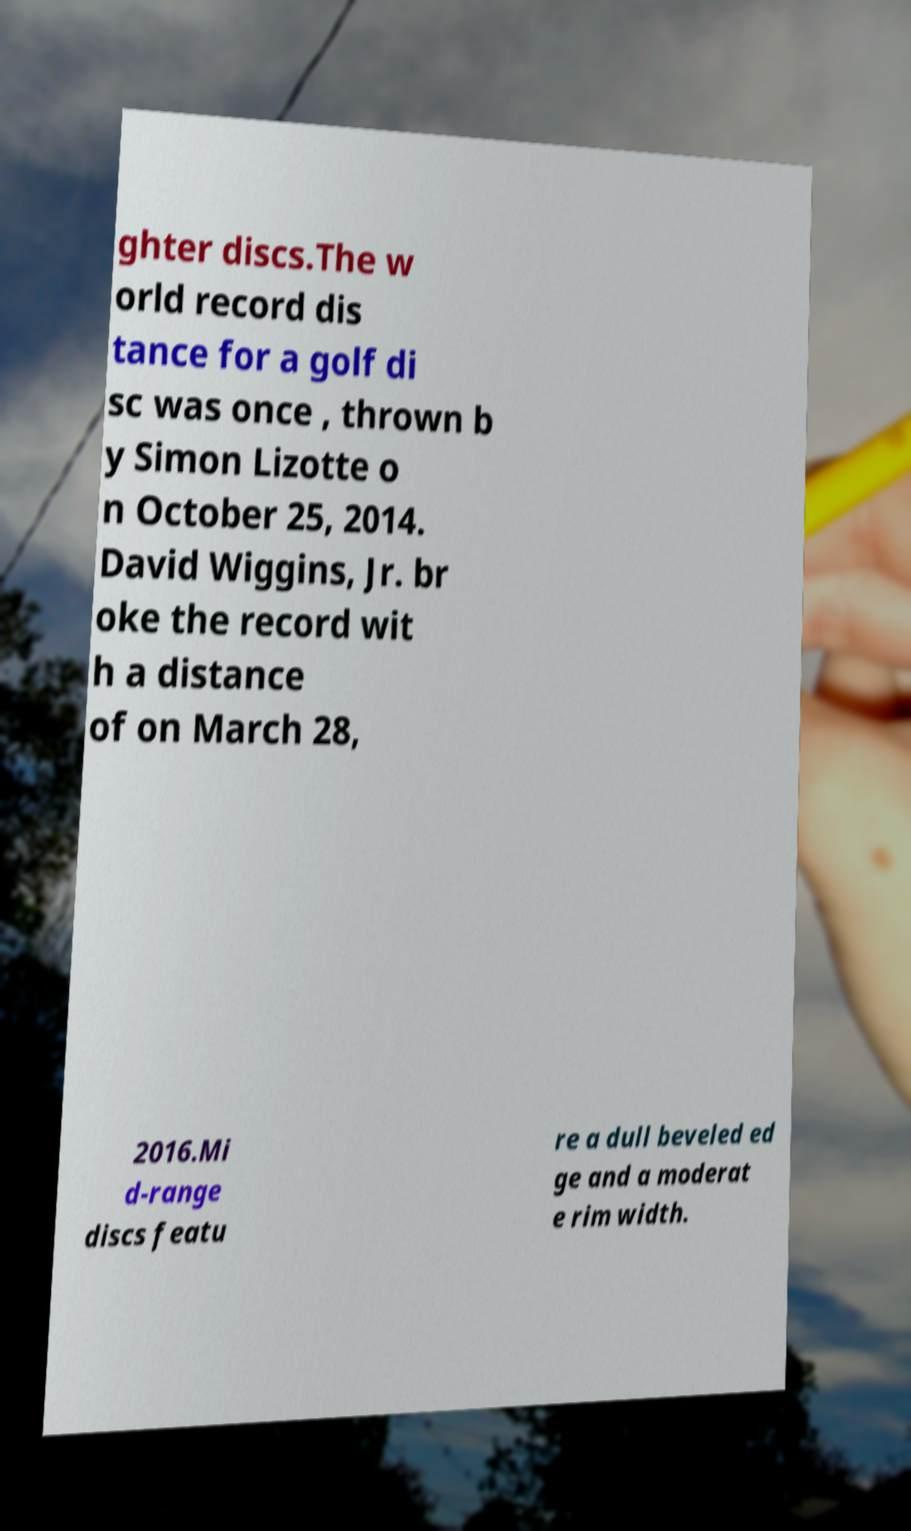Please identify and transcribe the text found in this image. ghter discs.The w orld record dis tance for a golf di sc was once , thrown b y Simon Lizotte o n October 25, 2014. David Wiggins, Jr. br oke the record wit h a distance of on March 28, 2016.Mi d-range discs featu re a dull beveled ed ge and a moderat e rim width. 